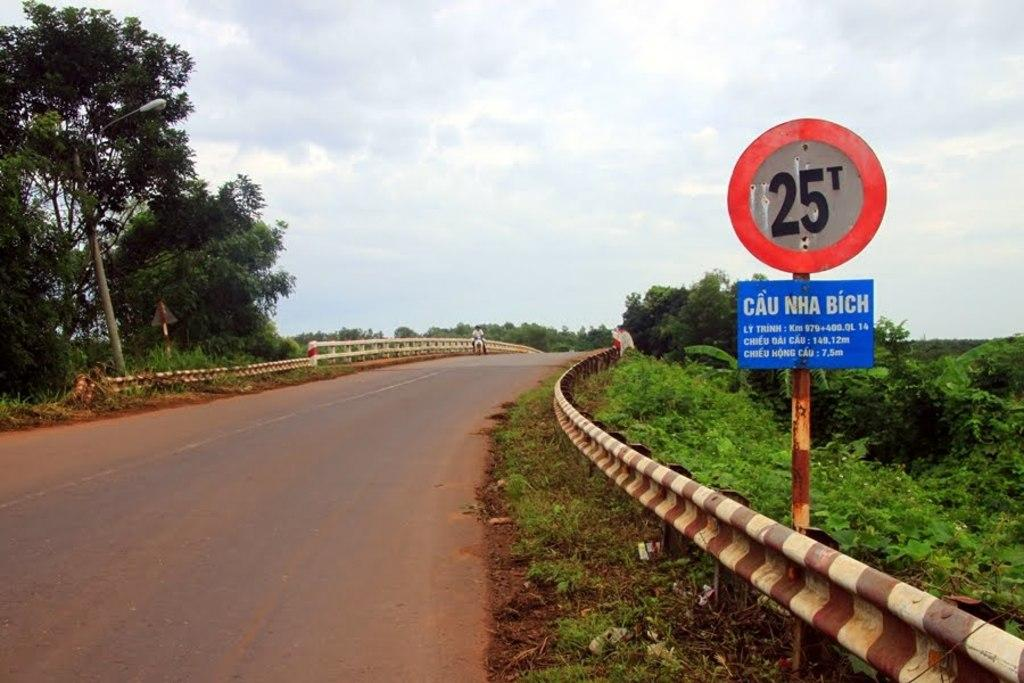<image>
Write a terse but informative summary of the picture. A circle with a border in red says 25 T. . 